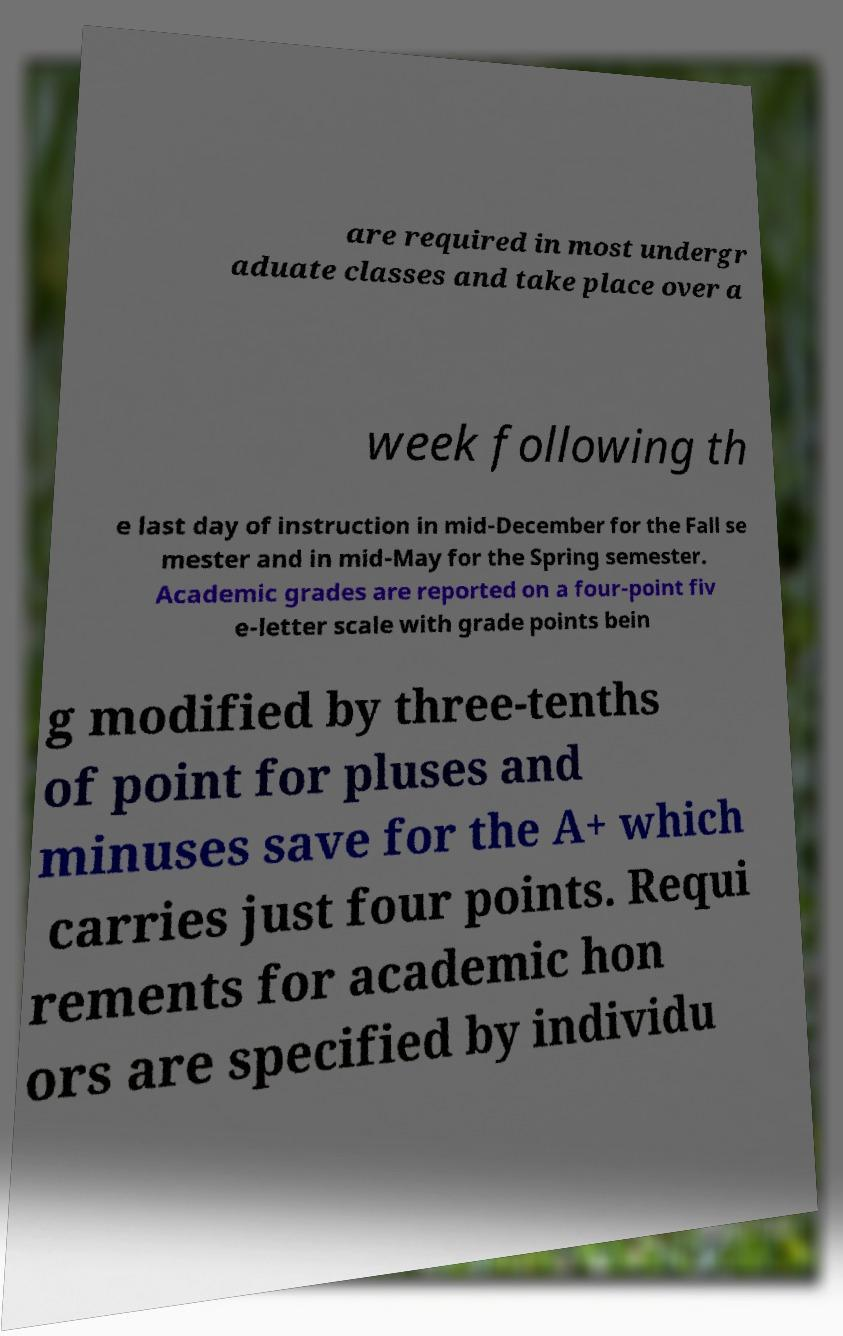Could you extract and type out the text from this image? are required in most undergr aduate classes and take place over a week following th e last day of instruction in mid-December for the Fall se mester and in mid-May for the Spring semester. Academic grades are reported on a four-point fiv e-letter scale with grade points bein g modified by three-tenths of point for pluses and minuses save for the A+ which carries just four points. Requi rements for academic hon ors are specified by individu 